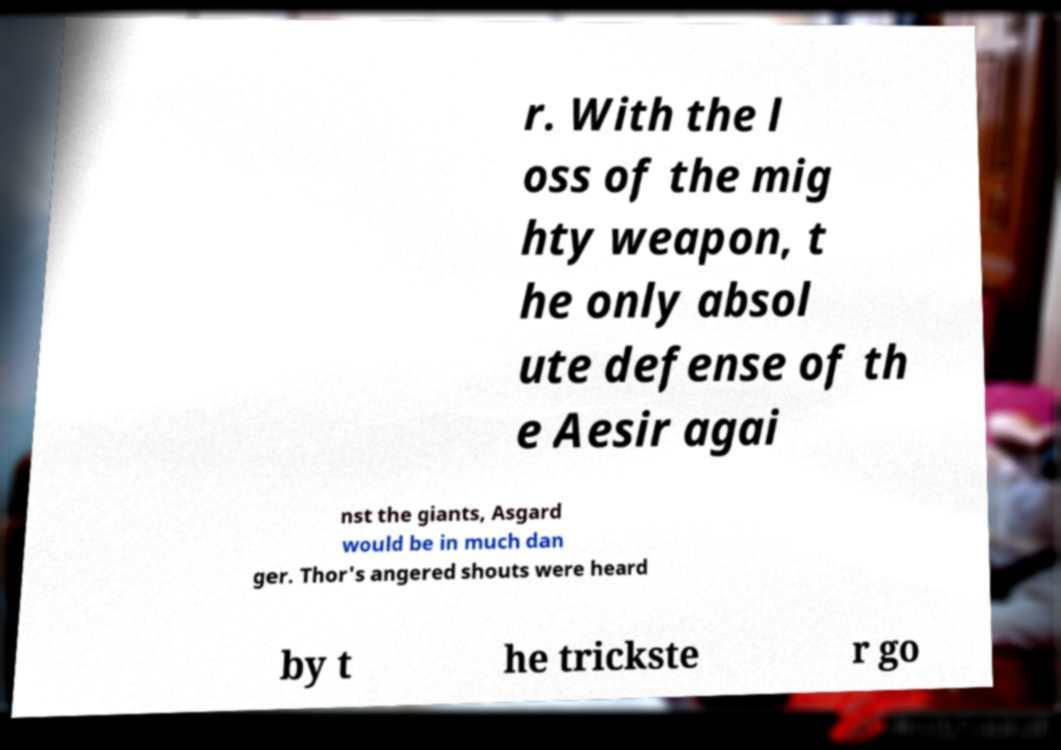There's text embedded in this image that I need extracted. Can you transcribe it verbatim? r. With the l oss of the mig hty weapon, t he only absol ute defense of th e Aesir agai nst the giants, Asgard would be in much dan ger. Thor's angered shouts were heard by t he trickste r go 